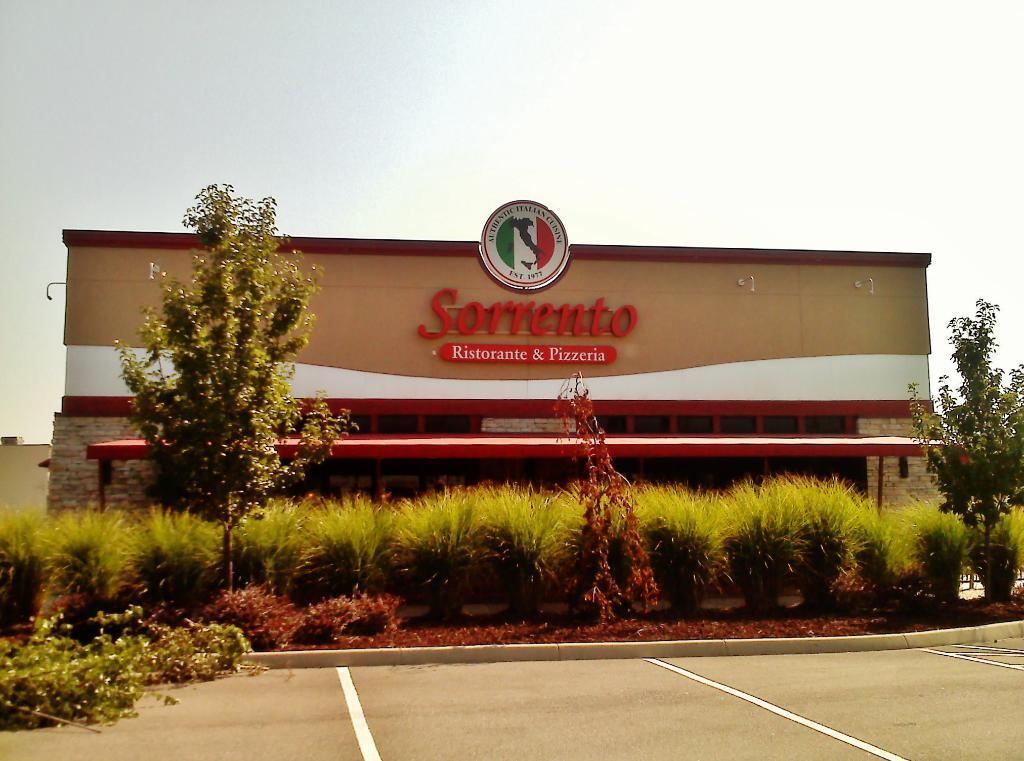Describe this image in one or two sentences. In the center of the image we can see the text and logo on the wall. At the bottom of the image we can see the road, plants, shed. At the top of the image we can see the sky. 